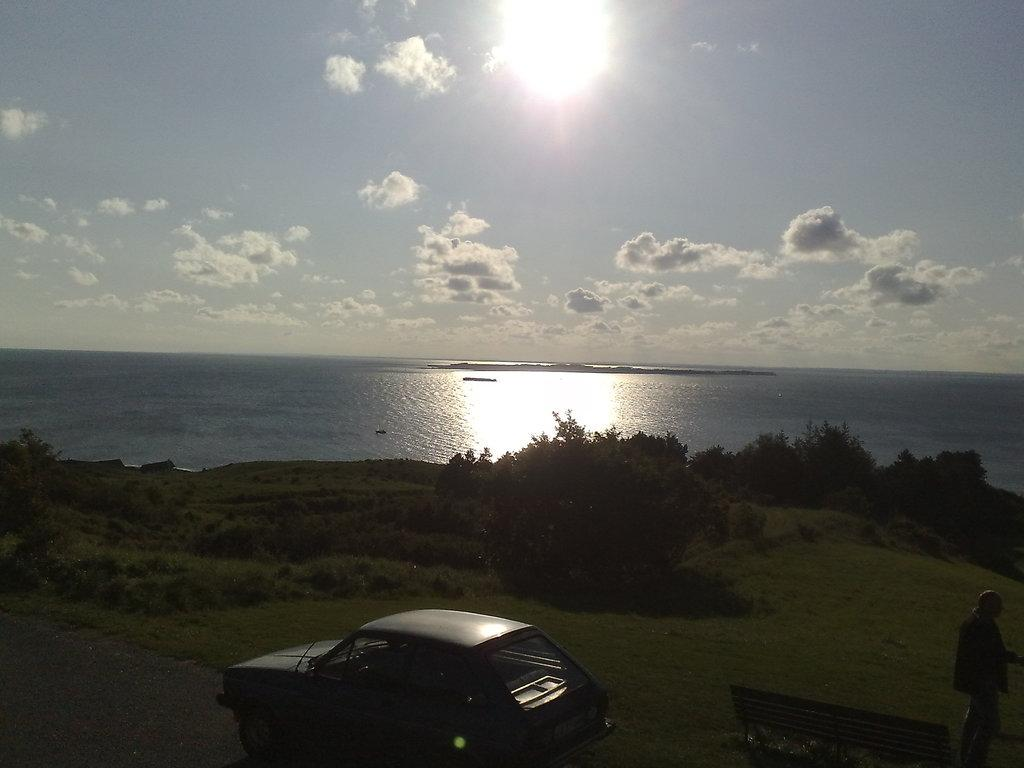What is the main subject in the image? There is a person standing in the image. What is the person standing near? There is a bench in the image. What can be seen on the road in the image? There is a car on the road in the image. What type of vegetation is present in the image? There is grass, plants, and trees in the image. What is visible in the background of the image? There is water and sky visible in the background of the image. What can be seen in the sky? There are clouds in the sky. How many balls can be seen rolling on the floor in the image? There are no balls or floors visible in the image. 